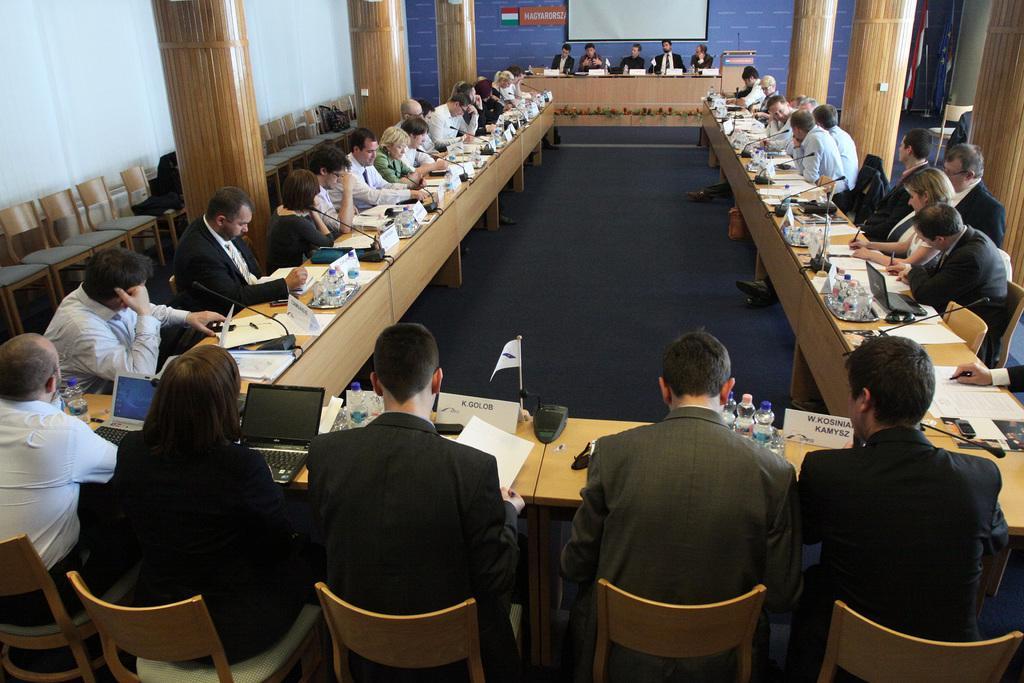Could you give a brief overview of what you see in this image? In this picture we can see a group of people sitting on chairs and in front of them there is table and on table we can see name board, flag, device,laptop, papers and in background we can see screen, pillar, wall, podium mic on it. 